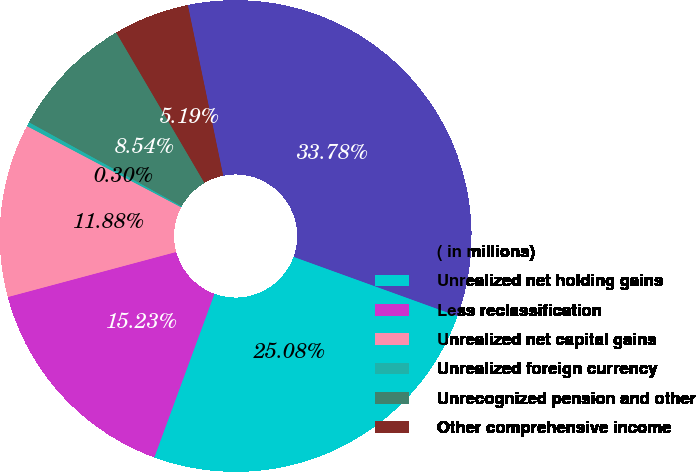Convert chart. <chart><loc_0><loc_0><loc_500><loc_500><pie_chart><fcel>( in millions)<fcel>Unrealized net holding gains<fcel>Less reclassification<fcel>Unrealized net capital gains<fcel>Unrealized foreign currency<fcel>Unrecognized pension and other<fcel>Other comprehensive income<nl><fcel>33.78%<fcel>25.08%<fcel>15.23%<fcel>11.88%<fcel>0.3%<fcel>8.54%<fcel>5.19%<nl></chart> 